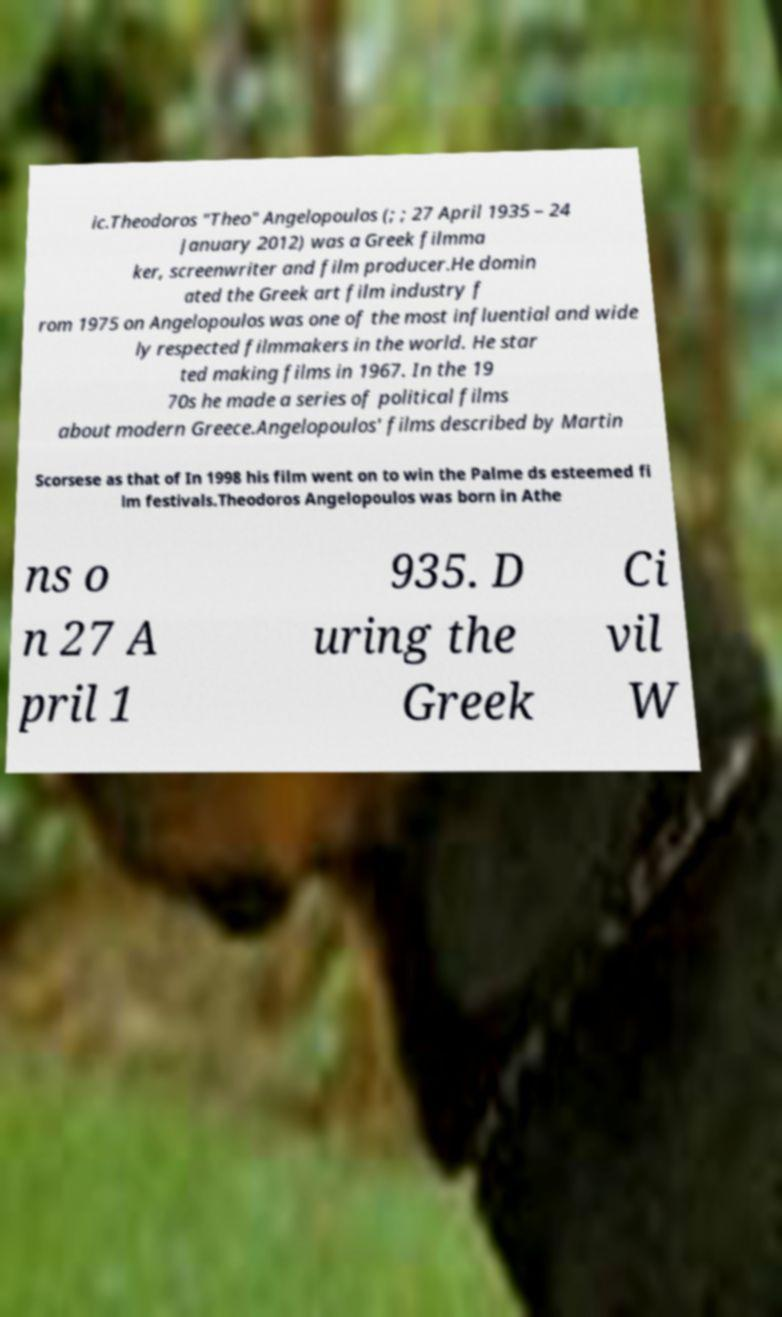I need the written content from this picture converted into text. Can you do that? ic.Theodoros "Theo" Angelopoulos (; ; 27 April 1935 – 24 January 2012) was a Greek filmma ker, screenwriter and film producer.He domin ated the Greek art film industry f rom 1975 on Angelopoulos was one of the most influential and wide ly respected filmmakers in the world. He star ted making films in 1967. In the 19 70s he made a series of political films about modern Greece.Angelopoulos' films described by Martin Scorsese as that of In 1998 his film went on to win the Palme ds esteemed fi lm festivals.Theodoros Angelopoulos was born in Athe ns o n 27 A pril 1 935. D uring the Greek Ci vil W 